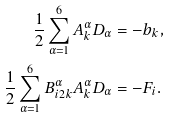<formula> <loc_0><loc_0><loc_500><loc_500>\frac { 1 } { 2 } \sum _ { \alpha = 1 } ^ { 6 } { A _ { k } ^ { \alpha } D _ { \alpha } } & = - b _ { k } , \\ \frac { 1 } { 2 } \sum _ { \alpha = 1 } ^ { 6 } { B _ { i 2 k } ^ { \alpha } A _ { k } ^ { \alpha } D _ { \alpha } } & = - F _ { i } .</formula> 